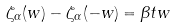<formula> <loc_0><loc_0><loc_500><loc_500>\zeta _ { \alpha } ( w ) - \zeta _ { \alpha } ( - w ) = \beta t w</formula> 